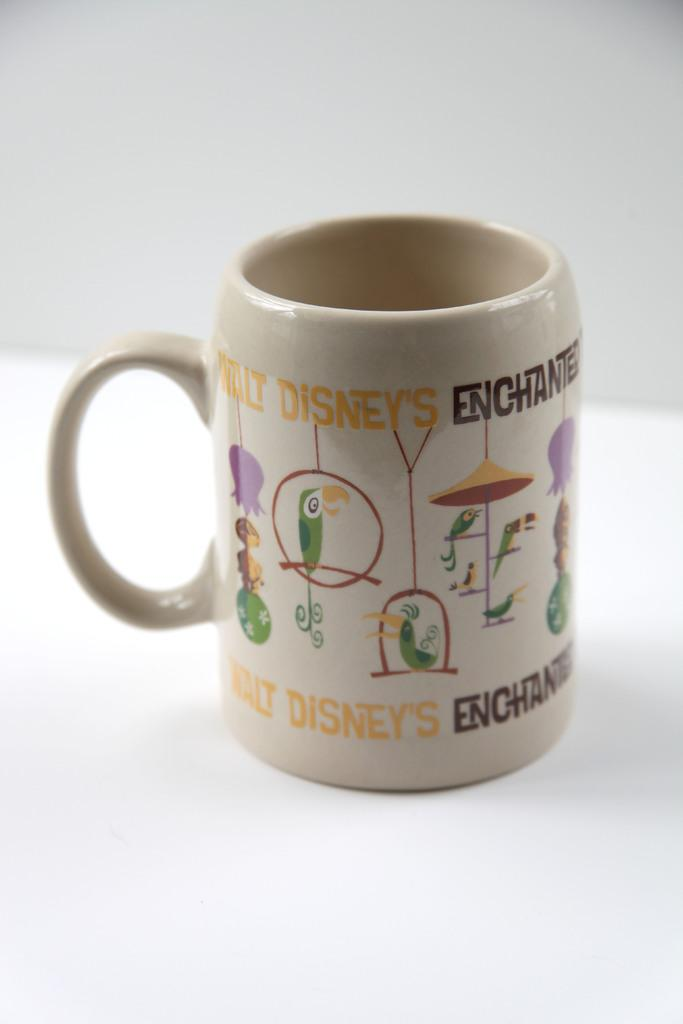Provide a one-sentence caption for the provided image. A mug that says Walt Disney's Enchanted and has birds on it. 